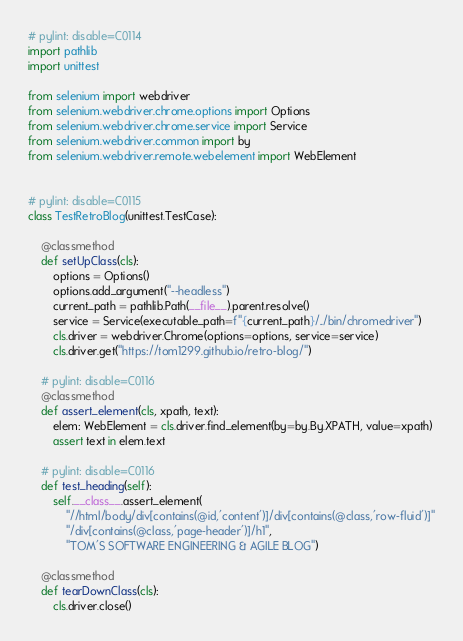<code> <loc_0><loc_0><loc_500><loc_500><_Python_># pylint: disable=C0114
import pathlib
import unittest

from selenium import webdriver
from selenium.webdriver.chrome.options import Options
from selenium.webdriver.chrome.service import Service
from selenium.webdriver.common import by
from selenium.webdriver.remote.webelement import WebElement


# pylint: disable=C0115
class TestRetroBlog(unittest.TestCase):

    @classmethod
    def setUpClass(cls):
        options = Options()
        options.add_argument("--headless")
        current_path = pathlib.Path(__file__).parent.resolve()
        service = Service(executable_path=f"{current_path}/../bin/chromedriver")
        cls.driver = webdriver.Chrome(options=options, service=service)
        cls.driver.get("https://tom1299.github.io/retro-blog/")

    # pylint: disable=C0116
    @classmethod
    def assert_element(cls, xpath, text):
        elem: WebElement = cls.driver.find_element(by=by.By.XPATH, value=xpath)
        assert text in elem.text

    # pylint: disable=C0116
    def test_heading(self):
        self.__class__.assert_element(
            "//html/body/div[contains(@id,'content')]/div[contains(@class,'row-fluid')]"
            "/div[contains(@class,'page-header')]/h1",
            "TOM'S SOFTWARE ENGINEERING & AGILE BLOG")

    @classmethod
    def tearDownClass(cls):
        cls.driver.close()
</code> 